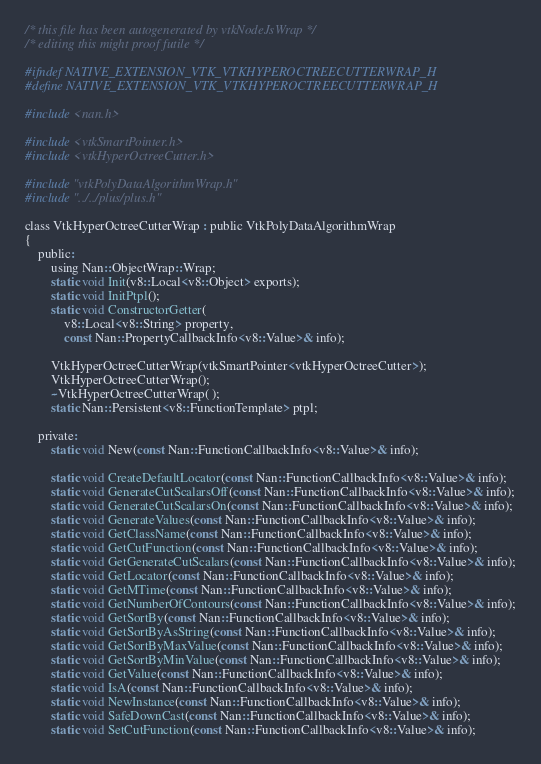<code> <loc_0><loc_0><loc_500><loc_500><_C_>/* this file has been autogenerated by vtkNodeJsWrap */
/* editing this might proof futile */

#ifndef NATIVE_EXTENSION_VTK_VTKHYPEROCTREECUTTERWRAP_H
#define NATIVE_EXTENSION_VTK_VTKHYPEROCTREECUTTERWRAP_H

#include <nan.h>

#include <vtkSmartPointer.h>
#include <vtkHyperOctreeCutter.h>

#include "vtkPolyDataAlgorithmWrap.h"
#include "../../plus/plus.h"

class VtkHyperOctreeCutterWrap : public VtkPolyDataAlgorithmWrap
{
	public:
		using Nan::ObjectWrap::Wrap;
		static void Init(v8::Local<v8::Object> exports);
		static void InitPtpl();
		static void ConstructorGetter(
			v8::Local<v8::String> property,
			const Nan::PropertyCallbackInfo<v8::Value>& info);

		VtkHyperOctreeCutterWrap(vtkSmartPointer<vtkHyperOctreeCutter>);
		VtkHyperOctreeCutterWrap();
		~VtkHyperOctreeCutterWrap( );
		static Nan::Persistent<v8::FunctionTemplate> ptpl;

	private:
		static void New(const Nan::FunctionCallbackInfo<v8::Value>& info);

		static void CreateDefaultLocator(const Nan::FunctionCallbackInfo<v8::Value>& info);
		static void GenerateCutScalarsOff(const Nan::FunctionCallbackInfo<v8::Value>& info);
		static void GenerateCutScalarsOn(const Nan::FunctionCallbackInfo<v8::Value>& info);
		static void GenerateValues(const Nan::FunctionCallbackInfo<v8::Value>& info);
		static void GetClassName(const Nan::FunctionCallbackInfo<v8::Value>& info);
		static void GetCutFunction(const Nan::FunctionCallbackInfo<v8::Value>& info);
		static void GetGenerateCutScalars(const Nan::FunctionCallbackInfo<v8::Value>& info);
		static void GetLocator(const Nan::FunctionCallbackInfo<v8::Value>& info);
		static void GetMTime(const Nan::FunctionCallbackInfo<v8::Value>& info);
		static void GetNumberOfContours(const Nan::FunctionCallbackInfo<v8::Value>& info);
		static void GetSortBy(const Nan::FunctionCallbackInfo<v8::Value>& info);
		static void GetSortByAsString(const Nan::FunctionCallbackInfo<v8::Value>& info);
		static void GetSortByMaxValue(const Nan::FunctionCallbackInfo<v8::Value>& info);
		static void GetSortByMinValue(const Nan::FunctionCallbackInfo<v8::Value>& info);
		static void GetValue(const Nan::FunctionCallbackInfo<v8::Value>& info);
		static void IsA(const Nan::FunctionCallbackInfo<v8::Value>& info);
		static void NewInstance(const Nan::FunctionCallbackInfo<v8::Value>& info);
		static void SafeDownCast(const Nan::FunctionCallbackInfo<v8::Value>& info);
		static void SetCutFunction(const Nan::FunctionCallbackInfo<v8::Value>& info);</code> 